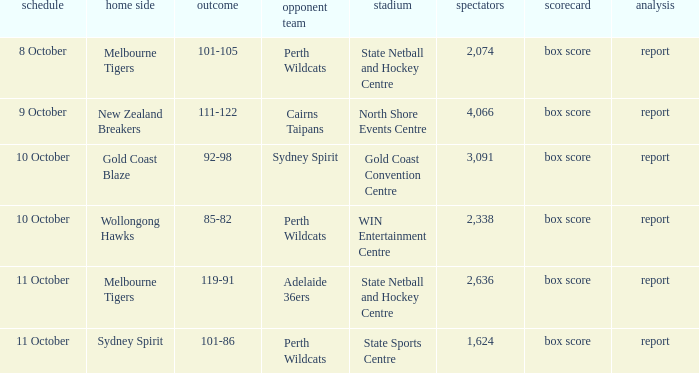What was the number of the crowd when the Wollongong Hawks were the home team? 2338.0. 